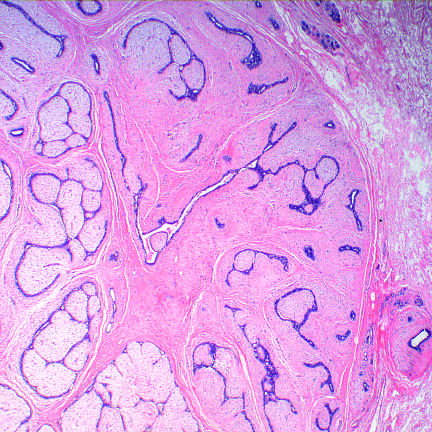does bone marrow from an infant have an expansile growth pattern with pushing circumscribed borders?
Answer the question using a single word or phrase. No 